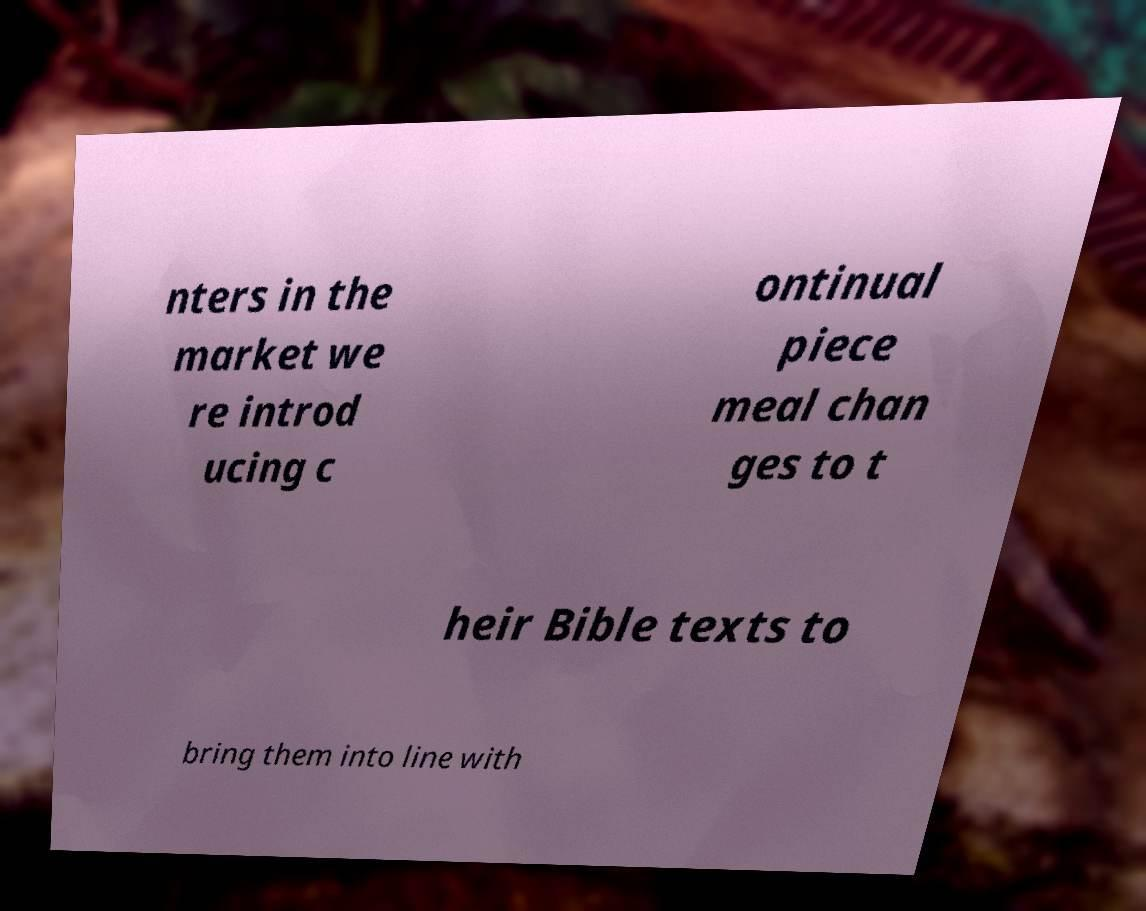Please read and relay the text visible in this image. What does it say? nters in the market we re introd ucing c ontinual piece meal chan ges to t heir Bible texts to bring them into line with 